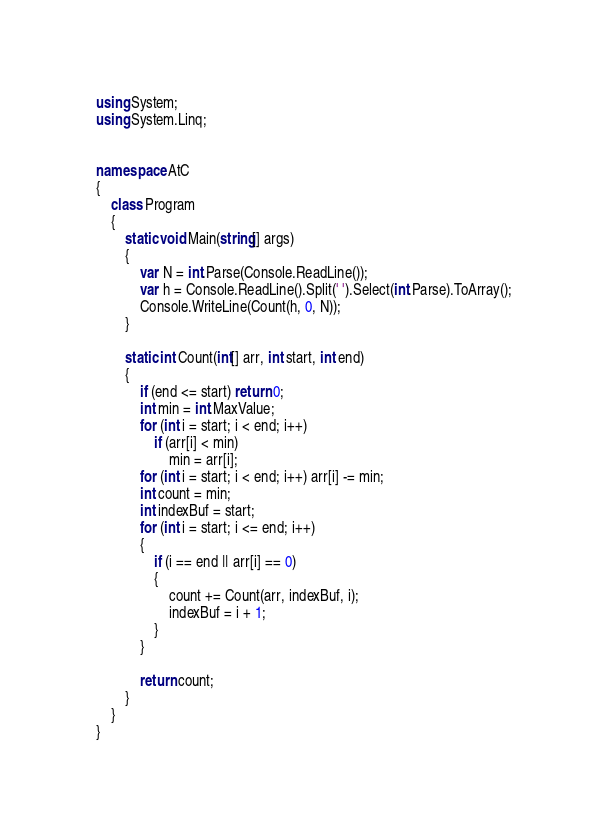Convert code to text. <code><loc_0><loc_0><loc_500><loc_500><_C#_>using System;
using System.Linq;


namespace AtC
{
    class Program
    {
        static void Main(string[] args)
        {
            var N = int.Parse(Console.ReadLine());
            var h = Console.ReadLine().Split(' ').Select(int.Parse).ToArray();
            Console.WriteLine(Count(h, 0, N));
        }

        static int Count(int[] arr, int start, int end)
        {
            if (end <= start) return 0;
            int min = int.MaxValue;
            for (int i = start; i < end; i++)
                if (arr[i] < min)
                    min = arr[i];
            for (int i = start; i < end; i++) arr[i] -= min;
            int count = min;
            int indexBuf = start;
            for (int i = start; i <= end; i++)
            {
                if (i == end || arr[i] == 0)
                {
                    count += Count(arr, indexBuf, i);
                    indexBuf = i + 1;
                }
            }

            return count;
        }
    }
}</code> 